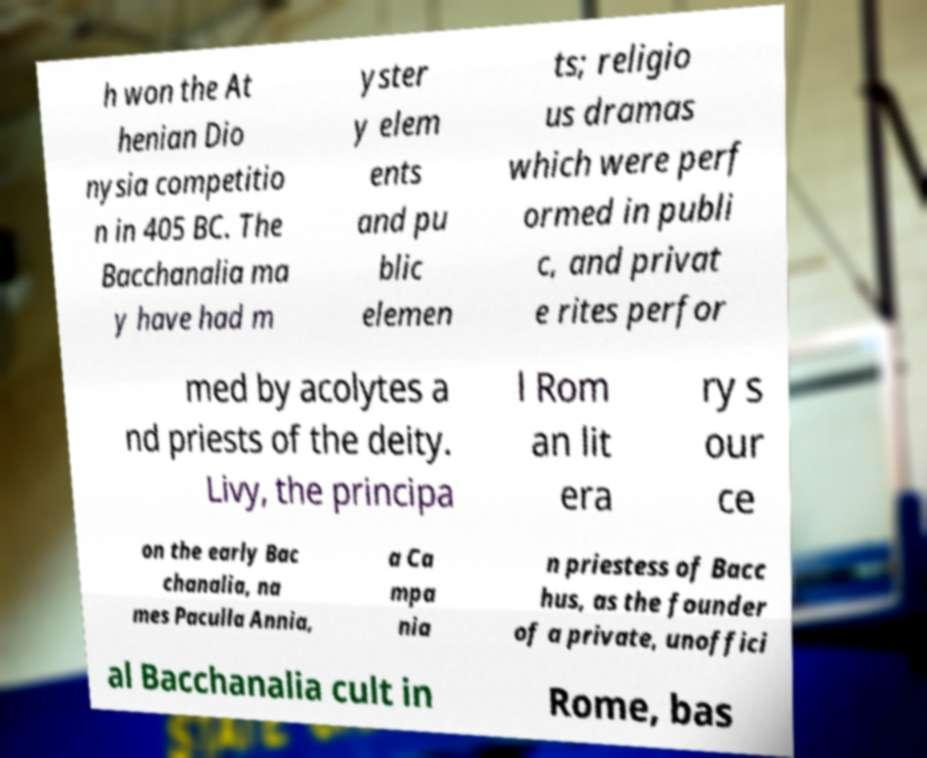Could you assist in decoding the text presented in this image and type it out clearly? h won the At henian Dio nysia competitio n in 405 BC. The Bacchanalia ma y have had m yster y elem ents and pu blic elemen ts; religio us dramas which were perf ormed in publi c, and privat e rites perfor med by acolytes a nd priests of the deity. Livy, the principa l Rom an lit era ry s our ce on the early Bac chanalia, na mes Paculla Annia, a Ca mpa nia n priestess of Bacc hus, as the founder of a private, unoffici al Bacchanalia cult in Rome, bas 